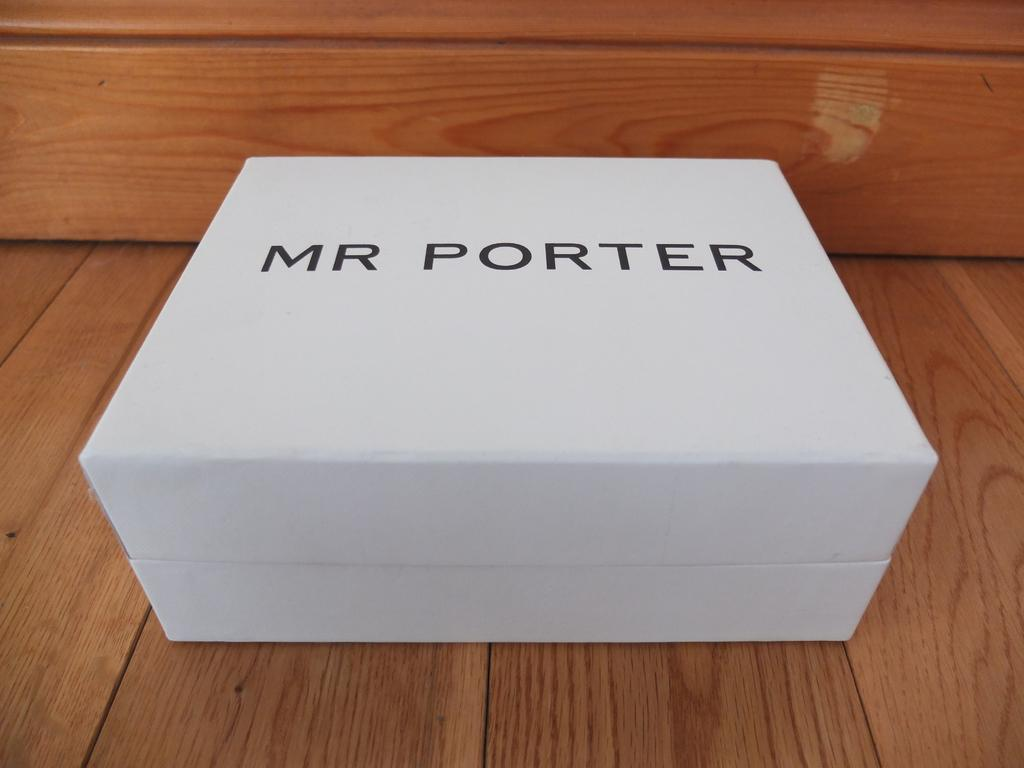<image>
Describe the image concisely. White square box with black letters Mr Porter 